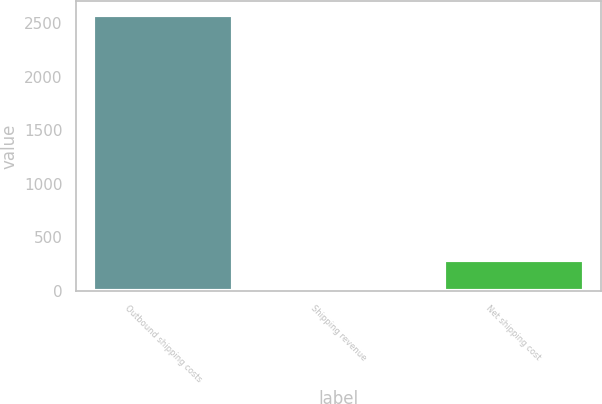<chart> <loc_0><loc_0><loc_500><loc_500><bar_chart><fcel>Outbound shipping costs<fcel>Shipping revenue<fcel>Net shipping cost<nl><fcel>2579<fcel>29<fcel>284<nl></chart> 